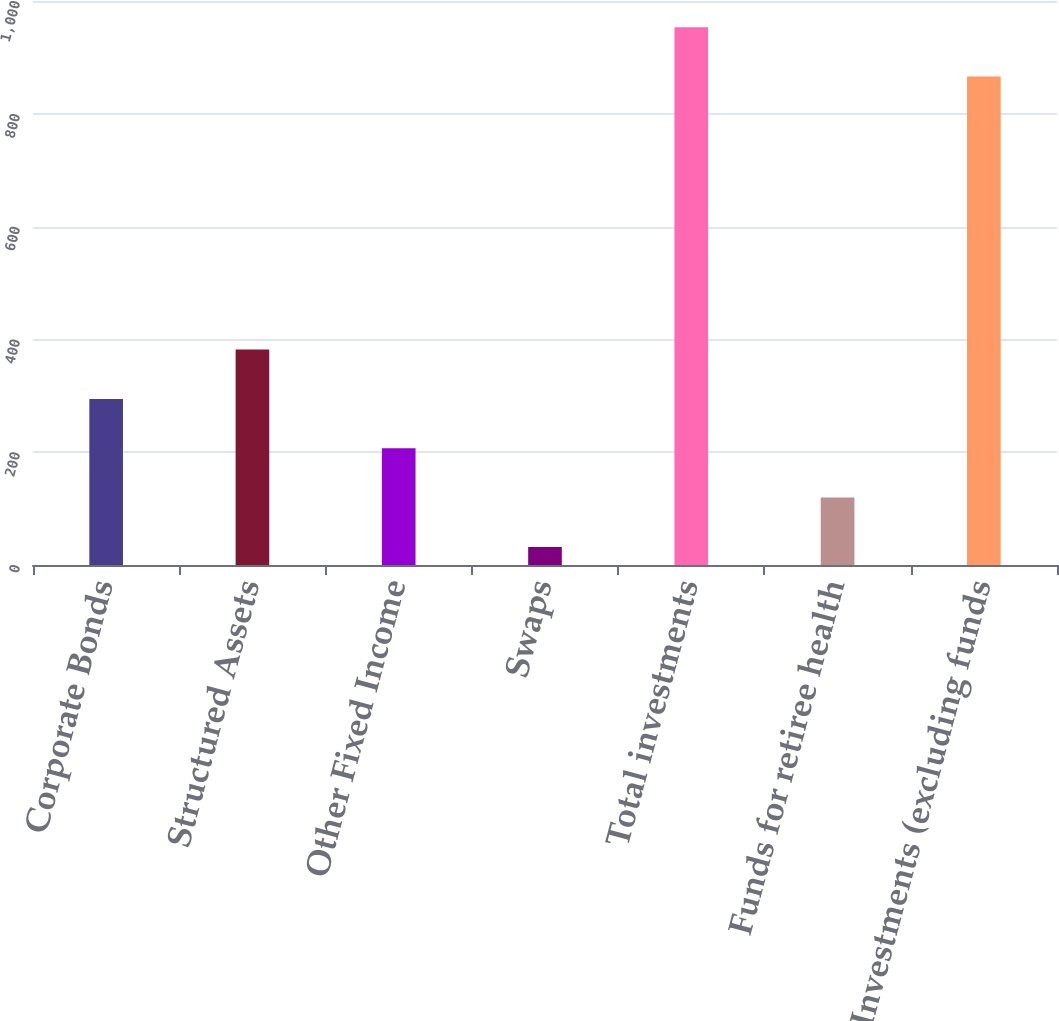Convert chart. <chart><loc_0><loc_0><loc_500><loc_500><bar_chart><fcel>Corporate Bonds<fcel>Structured Assets<fcel>Other Fixed Income<fcel>Swaps<fcel>Total investments<fcel>Funds for retiree health<fcel>Investments (excluding funds<nl><fcel>294.5<fcel>382<fcel>207<fcel>32<fcel>953.5<fcel>119.5<fcel>866<nl></chart> 